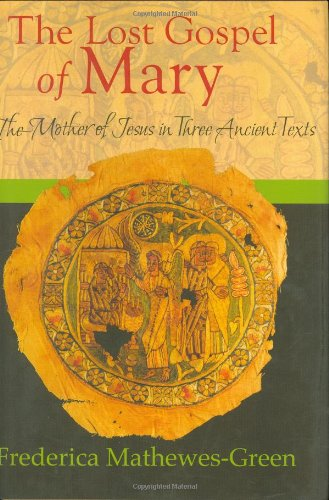Is this book related to Crafts, Hobbies & Home? No, this book is not related to Crafts, Hobbies & Home. Its focus is on religious texts and theological discussions concerning Mary, the mother of Jesus. 